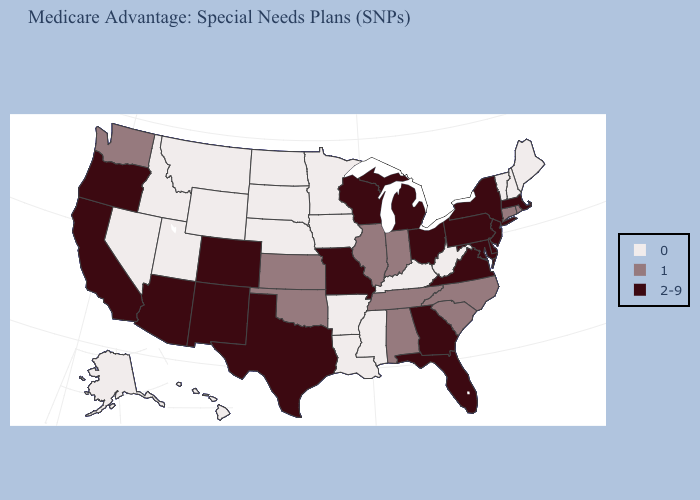Name the states that have a value in the range 0?
Be succinct. Alaska, Arkansas, Hawaii, Iowa, Idaho, Kentucky, Louisiana, Maine, Minnesota, Mississippi, Montana, North Dakota, Nebraska, New Hampshire, Nevada, South Dakota, Utah, Vermont, West Virginia, Wyoming. Does Minnesota have the highest value in the USA?
Keep it brief. No. Name the states that have a value in the range 2-9?
Short answer required. Arizona, California, Colorado, Delaware, Florida, Georgia, Massachusetts, Maryland, Michigan, Missouri, New Jersey, New Mexico, New York, Ohio, Oregon, Pennsylvania, Texas, Virginia, Wisconsin. Name the states that have a value in the range 2-9?
Answer briefly. Arizona, California, Colorado, Delaware, Florida, Georgia, Massachusetts, Maryland, Michigan, Missouri, New Jersey, New Mexico, New York, Ohio, Oregon, Pennsylvania, Texas, Virginia, Wisconsin. Among the states that border Washington , does Oregon have the highest value?
Answer briefly. Yes. Is the legend a continuous bar?
Answer briefly. No. What is the value of Pennsylvania?
Concise answer only. 2-9. Name the states that have a value in the range 2-9?
Write a very short answer. Arizona, California, Colorado, Delaware, Florida, Georgia, Massachusetts, Maryland, Michigan, Missouri, New Jersey, New Mexico, New York, Ohio, Oregon, Pennsylvania, Texas, Virginia, Wisconsin. What is the value of Vermont?
Give a very brief answer. 0. What is the highest value in the USA?
Quick response, please. 2-9. What is the value of Colorado?
Keep it brief. 2-9. Which states have the highest value in the USA?
Give a very brief answer. Arizona, California, Colorado, Delaware, Florida, Georgia, Massachusetts, Maryland, Michigan, Missouri, New Jersey, New Mexico, New York, Ohio, Oregon, Pennsylvania, Texas, Virginia, Wisconsin. What is the highest value in states that border North Dakota?
Be succinct. 0. Among the states that border Oregon , which have the highest value?
Be succinct. California. 